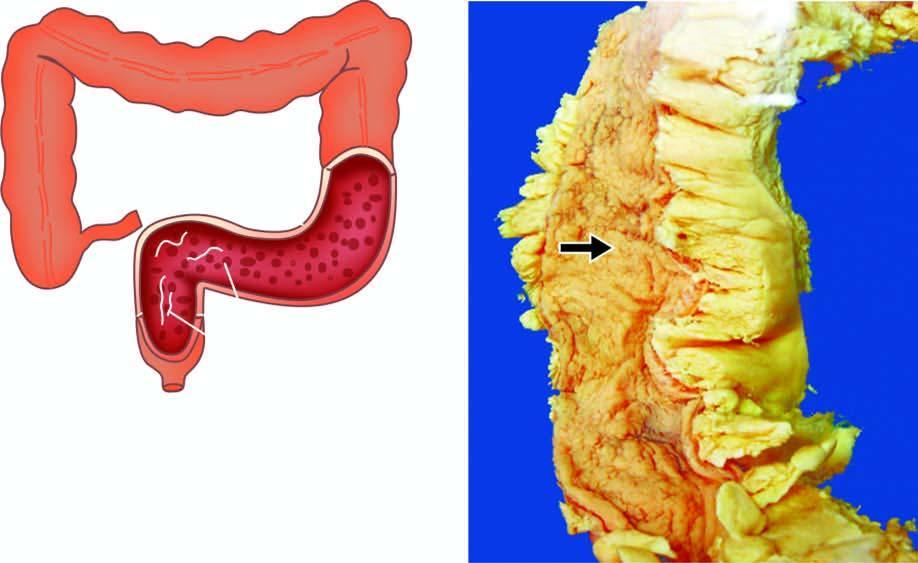what are the ulcers superficial with?
Answer the question using a single word or phrase. Intervening inflammatory pseudopolyps 